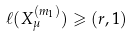<formula> <loc_0><loc_0><loc_500><loc_500>\ell ( X _ { \mu } ^ { ( m _ { 1 } ) } ) \geqslant ( r , 1 )</formula> 